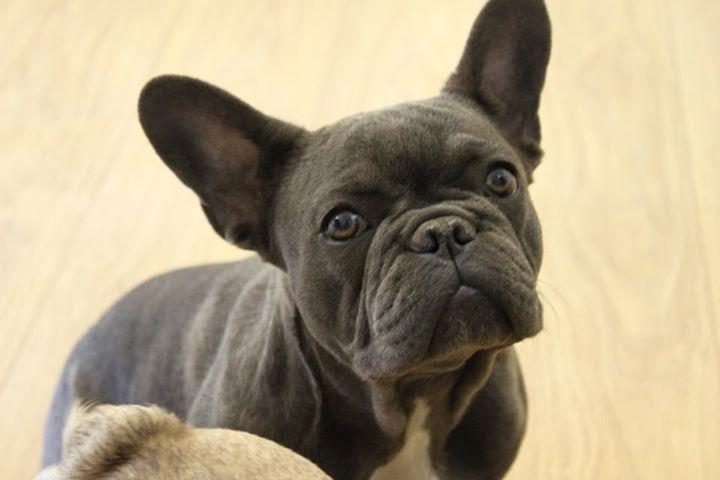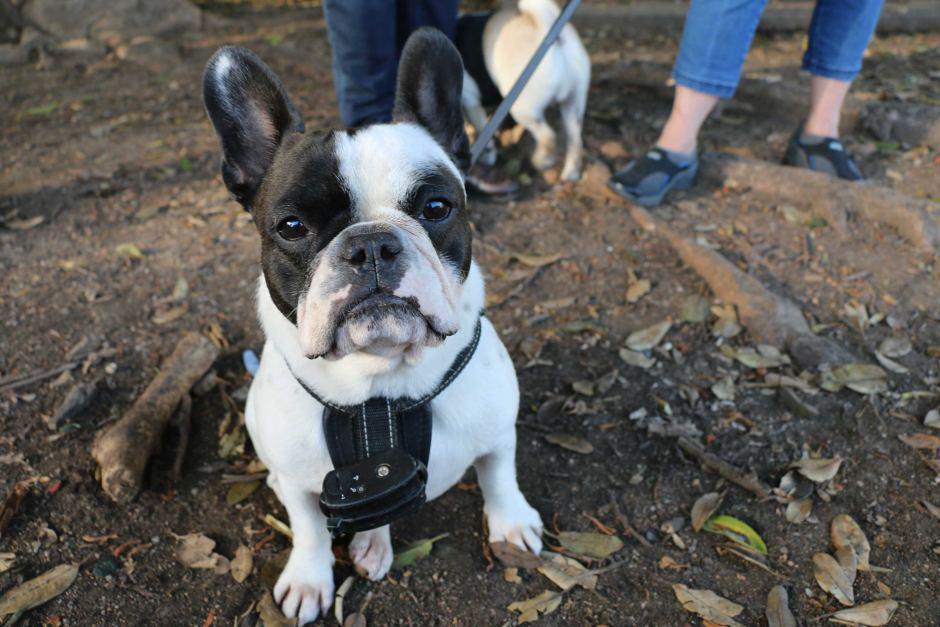The first image is the image on the left, the second image is the image on the right. Examine the images to the left and right. Is the description "At least one big-eared bulldog is standing on all fours on green grass, facing toward the camera." accurate? Answer yes or no. No. 